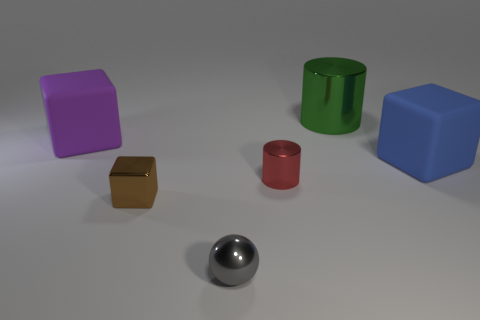Do the large matte thing left of the blue object and the gray thing in front of the big green metal cylinder have the same shape?
Keep it short and to the point. No. How many other objects are the same color as the big metal cylinder?
Make the answer very short. 0. There is a small object right of the tiny sphere that is in front of the matte block that is to the left of the big metal thing; what is its material?
Give a very brief answer. Metal. There is a large object in front of the block that is left of the brown thing; what is it made of?
Your response must be concise. Rubber. Is the number of big metal things that are on the left side of the purple block less than the number of tiny brown metal objects?
Offer a very short reply. Yes. What is the shape of the metal object left of the tiny gray sphere?
Offer a terse response. Cube. There is a purple rubber cube; is its size the same as the metal thing that is in front of the small brown thing?
Ensure brevity in your answer.  No. Is there a small red block made of the same material as the gray sphere?
Offer a terse response. No. How many cubes are either red shiny objects or large purple things?
Offer a terse response. 1. There is a rubber thing that is to the right of the tiny gray shiny sphere; is there a big rubber object that is behind it?
Give a very brief answer. Yes. 